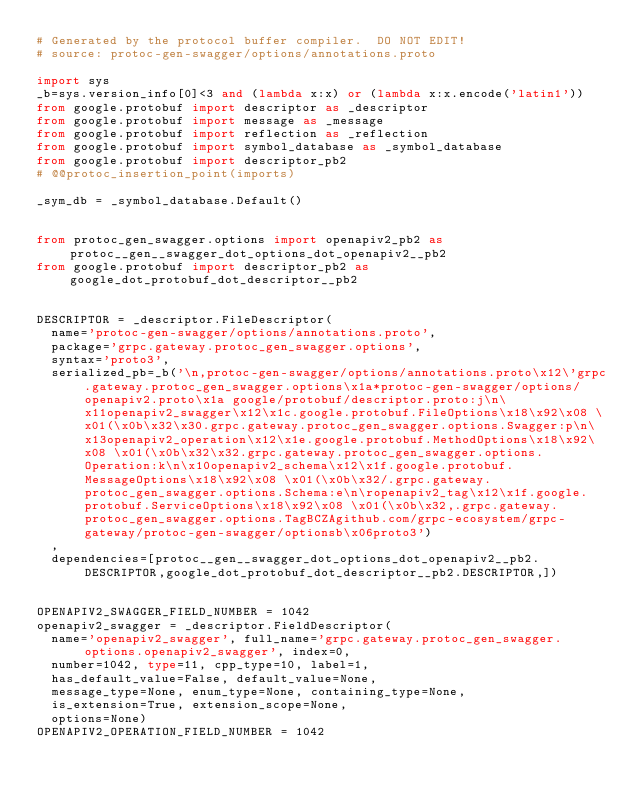<code> <loc_0><loc_0><loc_500><loc_500><_Python_># Generated by the protocol buffer compiler.  DO NOT EDIT!
# source: protoc-gen-swagger/options/annotations.proto

import sys
_b=sys.version_info[0]<3 and (lambda x:x) or (lambda x:x.encode('latin1'))
from google.protobuf import descriptor as _descriptor
from google.protobuf import message as _message
from google.protobuf import reflection as _reflection
from google.protobuf import symbol_database as _symbol_database
from google.protobuf import descriptor_pb2
# @@protoc_insertion_point(imports)

_sym_db = _symbol_database.Default()


from protoc_gen_swagger.options import openapiv2_pb2 as protoc__gen__swagger_dot_options_dot_openapiv2__pb2
from google.protobuf import descriptor_pb2 as google_dot_protobuf_dot_descriptor__pb2


DESCRIPTOR = _descriptor.FileDescriptor(
  name='protoc-gen-swagger/options/annotations.proto',
  package='grpc.gateway.protoc_gen_swagger.options',
  syntax='proto3',
  serialized_pb=_b('\n,protoc-gen-swagger/options/annotations.proto\x12\'grpc.gateway.protoc_gen_swagger.options\x1a*protoc-gen-swagger/options/openapiv2.proto\x1a google/protobuf/descriptor.proto:j\n\x11openapiv2_swagger\x12\x1c.google.protobuf.FileOptions\x18\x92\x08 \x01(\x0b\x32\x30.grpc.gateway.protoc_gen_swagger.options.Swagger:p\n\x13openapiv2_operation\x12\x1e.google.protobuf.MethodOptions\x18\x92\x08 \x01(\x0b\x32\x32.grpc.gateway.protoc_gen_swagger.options.Operation:k\n\x10openapiv2_schema\x12\x1f.google.protobuf.MessageOptions\x18\x92\x08 \x01(\x0b\x32/.grpc.gateway.protoc_gen_swagger.options.Schema:e\n\ropenapiv2_tag\x12\x1f.google.protobuf.ServiceOptions\x18\x92\x08 \x01(\x0b\x32,.grpc.gateway.protoc_gen_swagger.options.TagBCZAgithub.com/grpc-ecosystem/grpc-gateway/protoc-gen-swagger/optionsb\x06proto3')
  ,
  dependencies=[protoc__gen__swagger_dot_options_dot_openapiv2__pb2.DESCRIPTOR,google_dot_protobuf_dot_descriptor__pb2.DESCRIPTOR,])


OPENAPIV2_SWAGGER_FIELD_NUMBER = 1042
openapiv2_swagger = _descriptor.FieldDescriptor(
  name='openapiv2_swagger', full_name='grpc.gateway.protoc_gen_swagger.options.openapiv2_swagger', index=0,
  number=1042, type=11, cpp_type=10, label=1,
  has_default_value=False, default_value=None,
  message_type=None, enum_type=None, containing_type=None,
  is_extension=True, extension_scope=None,
  options=None)
OPENAPIV2_OPERATION_FIELD_NUMBER = 1042</code> 